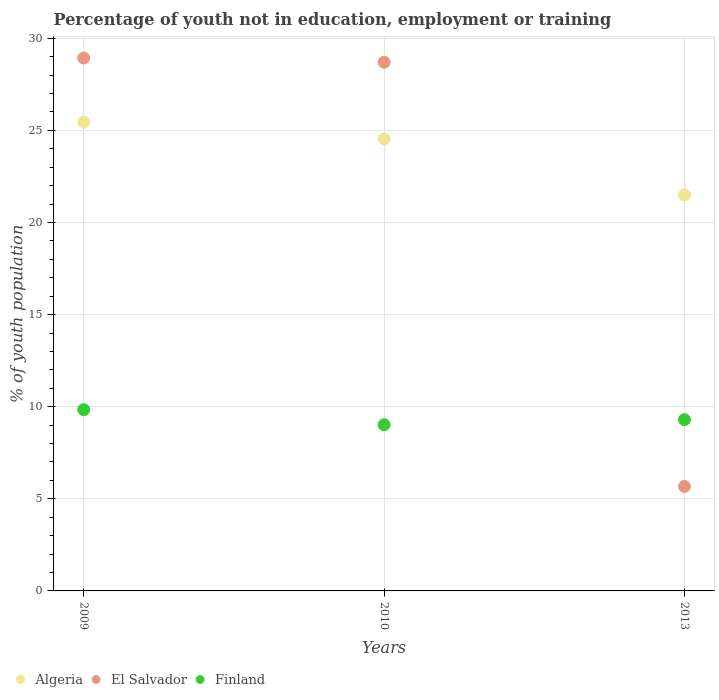Is the number of dotlines equal to the number of legend labels?
Give a very brief answer. Yes. What is the percentage of unemployed youth population in in Algeria in 2010?
Ensure brevity in your answer.  24.53. Across all years, what is the maximum percentage of unemployed youth population in in Finland?
Make the answer very short. 9.84. Across all years, what is the minimum percentage of unemployed youth population in in Finland?
Give a very brief answer. 9.02. In which year was the percentage of unemployed youth population in in El Salvador maximum?
Offer a very short reply. 2009. What is the total percentage of unemployed youth population in in El Salvador in the graph?
Offer a very short reply. 63.3. What is the difference between the percentage of unemployed youth population in in El Salvador in 2009 and that in 2013?
Provide a short and direct response. 23.26. What is the difference between the percentage of unemployed youth population in in El Salvador in 2009 and the percentage of unemployed youth population in in Finland in 2010?
Keep it short and to the point. 19.91. What is the average percentage of unemployed youth population in in El Salvador per year?
Offer a terse response. 21.1. In the year 2009, what is the difference between the percentage of unemployed youth population in in El Salvador and percentage of unemployed youth population in in Finland?
Your answer should be compact. 19.09. In how many years, is the percentage of unemployed youth population in in El Salvador greater than 8 %?
Ensure brevity in your answer.  2. What is the ratio of the percentage of unemployed youth population in in Algeria in 2009 to that in 2013?
Make the answer very short. 1.18. Is the percentage of unemployed youth population in in El Salvador in 2010 less than that in 2013?
Provide a short and direct response. No. What is the difference between the highest and the second highest percentage of unemployed youth population in in Finland?
Keep it short and to the point. 0.54. What is the difference between the highest and the lowest percentage of unemployed youth population in in El Salvador?
Make the answer very short. 23.26. In how many years, is the percentage of unemployed youth population in in El Salvador greater than the average percentage of unemployed youth population in in El Salvador taken over all years?
Keep it short and to the point. 2. Is the sum of the percentage of unemployed youth population in in Finland in 2010 and 2013 greater than the maximum percentage of unemployed youth population in in El Salvador across all years?
Offer a very short reply. No. Does the percentage of unemployed youth population in in Algeria monotonically increase over the years?
Ensure brevity in your answer.  No. Is the percentage of unemployed youth population in in Algeria strictly less than the percentage of unemployed youth population in in Finland over the years?
Your answer should be very brief. No. How many dotlines are there?
Your answer should be very brief. 3. What is the difference between two consecutive major ticks on the Y-axis?
Your answer should be compact. 5. Does the graph contain any zero values?
Keep it short and to the point. No. Does the graph contain grids?
Ensure brevity in your answer.  Yes. How are the legend labels stacked?
Ensure brevity in your answer.  Horizontal. What is the title of the graph?
Ensure brevity in your answer.  Percentage of youth not in education, employment or training. Does "Comoros" appear as one of the legend labels in the graph?
Give a very brief answer. No. What is the label or title of the Y-axis?
Give a very brief answer. % of youth population. What is the % of youth population in Algeria in 2009?
Keep it short and to the point. 25.45. What is the % of youth population of El Salvador in 2009?
Your answer should be very brief. 28.93. What is the % of youth population in Finland in 2009?
Your answer should be compact. 9.84. What is the % of youth population in Algeria in 2010?
Offer a terse response. 24.53. What is the % of youth population in El Salvador in 2010?
Your answer should be very brief. 28.7. What is the % of youth population of Finland in 2010?
Ensure brevity in your answer.  9.02. What is the % of youth population of Algeria in 2013?
Provide a succinct answer. 21.5. What is the % of youth population of El Salvador in 2013?
Ensure brevity in your answer.  5.67. What is the % of youth population in Finland in 2013?
Make the answer very short. 9.3. Across all years, what is the maximum % of youth population in Algeria?
Ensure brevity in your answer.  25.45. Across all years, what is the maximum % of youth population in El Salvador?
Your response must be concise. 28.93. Across all years, what is the maximum % of youth population in Finland?
Offer a terse response. 9.84. Across all years, what is the minimum % of youth population in El Salvador?
Provide a short and direct response. 5.67. Across all years, what is the minimum % of youth population in Finland?
Your answer should be compact. 9.02. What is the total % of youth population of Algeria in the graph?
Your answer should be compact. 71.48. What is the total % of youth population of El Salvador in the graph?
Your answer should be very brief. 63.3. What is the total % of youth population in Finland in the graph?
Make the answer very short. 28.16. What is the difference between the % of youth population of Algeria in 2009 and that in 2010?
Ensure brevity in your answer.  0.92. What is the difference between the % of youth population in El Salvador in 2009 and that in 2010?
Keep it short and to the point. 0.23. What is the difference between the % of youth population in Finland in 2009 and that in 2010?
Offer a terse response. 0.82. What is the difference between the % of youth population in Algeria in 2009 and that in 2013?
Provide a short and direct response. 3.95. What is the difference between the % of youth population of El Salvador in 2009 and that in 2013?
Give a very brief answer. 23.26. What is the difference between the % of youth population in Finland in 2009 and that in 2013?
Offer a very short reply. 0.54. What is the difference between the % of youth population in Algeria in 2010 and that in 2013?
Your answer should be compact. 3.03. What is the difference between the % of youth population of El Salvador in 2010 and that in 2013?
Offer a very short reply. 23.03. What is the difference between the % of youth population in Finland in 2010 and that in 2013?
Your response must be concise. -0.28. What is the difference between the % of youth population in Algeria in 2009 and the % of youth population in El Salvador in 2010?
Provide a succinct answer. -3.25. What is the difference between the % of youth population in Algeria in 2009 and the % of youth population in Finland in 2010?
Offer a terse response. 16.43. What is the difference between the % of youth population in El Salvador in 2009 and the % of youth population in Finland in 2010?
Keep it short and to the point. 19.91. What is the difference between the % of youth population in Algeria in 2009 and the % of youth population in El Salvador in 2013?
Ensure brevity in your answer.  19.78. What is the difference between the % of youth population in Algeria in 2009 and the % of youth population in Finland in 2013?
Offer a terse response. 16.15. What is the difference between the % of youth population of El Salvador in 2009 and the % of youth population of Finland in 2013?
Ensure brevity in your answer.  19.63. What is the difference between the % of youth population of Algeria in 2010 and the % of youth population of El Salvador in 2013?
Your answer should be compact. 18.86. What is the difference between the % of youth population in Algeria in 2010 and the % of youth population in Finland in 2013?
Your answer should be compact. 15.23. What is the average % of youth population of Algeria per year?
Your answer should be compact. 23.83. What is the average % of youth population of El Salvador per year?
Provide a short and direct response. 21.1. What is the average % of youth population of Finland per year?
Provide a short and direct response. 9.39. In the year 2009, what is the difference between the % of youth population in Algeria and % of youth population in El Salvador?
Offer a very short reply. -3.48. In the year 2009, what is the difference between the % of youth population of Algeria and % of youth population of Finland?
Give a very brief answer. 15.61. In the year 2009, what is the difference between the % of youth population of El Salvador and % of youth population of Finland?
Give a very brief answer. 19.09. In the year 2010, what is the difference between the % of youth population in Algeria and % of youth population in El Salvador?
Ensure brevity in your answer.  -4.17. In the year 2010, what is the difference between the % of youth population of Algeria and % of youth population of Finland?
Your answer should be very brief. 15.51. In the year 2010, what is the difference between the % of youth population in El Salvador and % of youth population in Finland?
Offer a terse response. 19.68. In the year 2013, what is the difference between the % of youth population in Algeria and % of youth population in El Salvador?
Provide a short and direct response. 15.83. In the year 2013, what is the difference between the % of youth population in El Salvador and % of youth population in Finland?
Provide a short and direct response. -3.63. What is the ratio of the % of youth population in Algeria in 2009 to that in 2010?
Ensure brevity in your answer.  1.04. What is the ratio of the % of youth population of El Salvador in 2009 to that in 2010?
Provide a short and direct response. 1.01. What is the ratio of the % of youth population in Algeria in 2009 to that in 2013?
Your answer should be compact. 1.18. What is the ratio of the % of youth population in El Salvador in 2009 to that in 2013?
Your answer should be compact. 5.1. What is the ratio of the % of youth population in Finland in 2009 to that in 2013?
Provide a short and direct response. 1.06. What is the ratio of the % of youth population in Algeria in 2010 to that in 2013?
Keep it short and to the point. 1.14. What is the ratio of the % of youth population in El Salvador in 2010 to that in 2013?
Keep it short and to the point. 5.06. What is the ratio of the % of youth population in Finland in 2010 to that in 2013?
Your answer should be very brief. 0.97. What is the difference between the highest and the second highest % of youth population in El Salvador?
Offer a terse response. 0.23. What is the difference between the highest and the second highest % of youth population of Finland?
Offer a terse response. 0.54. What is the difference between the highest and the lowest % of youth population of Algeria?
Your answer should be compact. 3.95. What is the difference between the highest and the lowest % of youth population in El Salvador?
Your response must be concise. 23.26. What is the difference between the highest and the lowest % of youth population in Finland?
Make the answer very short. 0.82. 